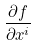Convert formula to latex. <formula><loc_0><loc_0><loc_500><loc_500>\frac { \partial f } { \partial x ^ { i } }</formula> 